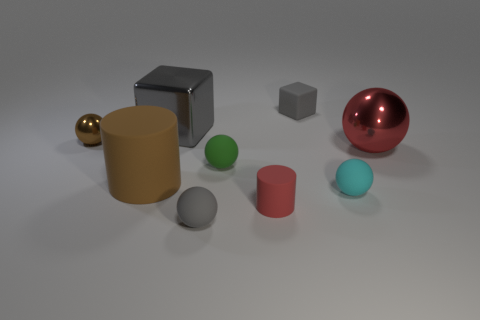What number of small spheres are to the right of the rubber cube and to the left of the tiny gray cube?
Your answer should be compact. 0. What number of other objects are there of the same color as the metal block?
Provide a succinct answer. 2. How many gray things are either metallic cubes or big metallic spheres?
Give a very brief answer. 1. The red shiny thing has what size?
Give a very brief answer. Large. What number of matte objects are small things or big green objects?
Your response must be concise. 5. Are there fewer yellow matte cubes than gray blocks?
Keep it short and to the point. Yes. How many other things are made of the same material as the large cylinder?
Your answer should be very brief. 5. There is another rubber thing that is the same shape as the large brown object; what is its size?
Give a very brief answer. Small. Does the big object that is in front of the red shiny thing have the same material as the tiny brown object that is to the left of the cyan sphere?
Your response must be concise. No. Is the number of blocks right of the small green sphere less than the number of spheres?
Offer a very short reply. Yes. 